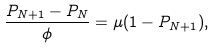Convert formula to latex. <formula><loc_0><loc_0><loc_500><loc_500>\frac { P _ { N + 1 } - P _ { N } } { \phi } = \mu ( 1 - P _ { N + 1 } ) ,</formula> 